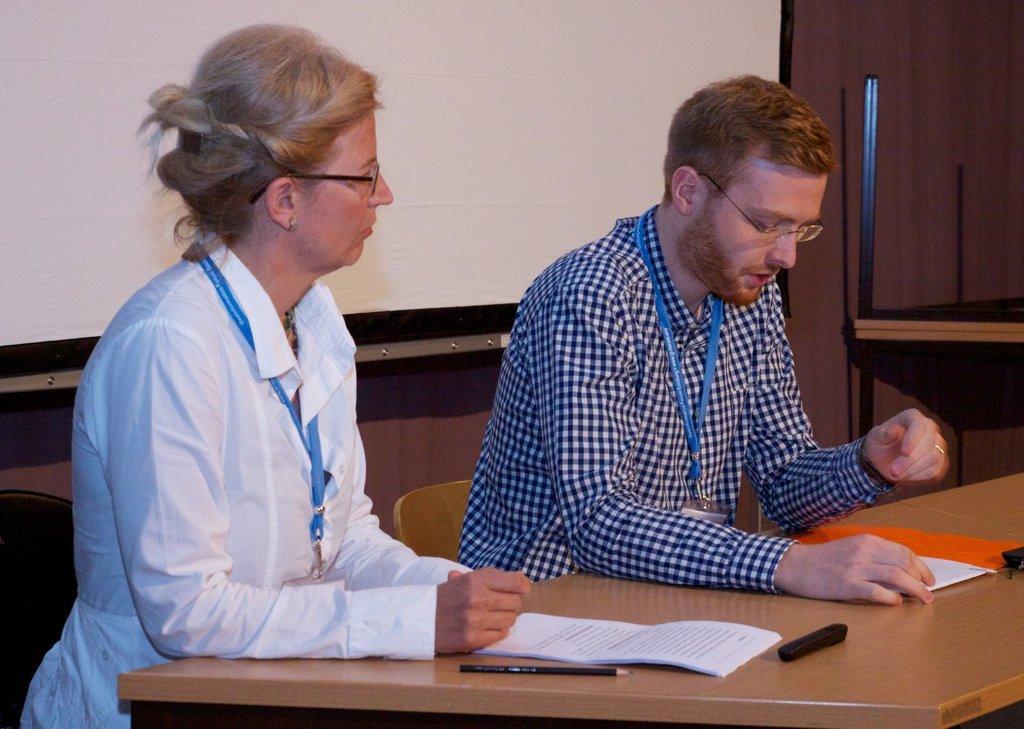Can you describe this image briefly? This is the picture of a room. In this image there are two persons sitting behind the table. There are papers and there is a pencil, marker on the table. At the back there is a screen and there is a wall and there are tables. 